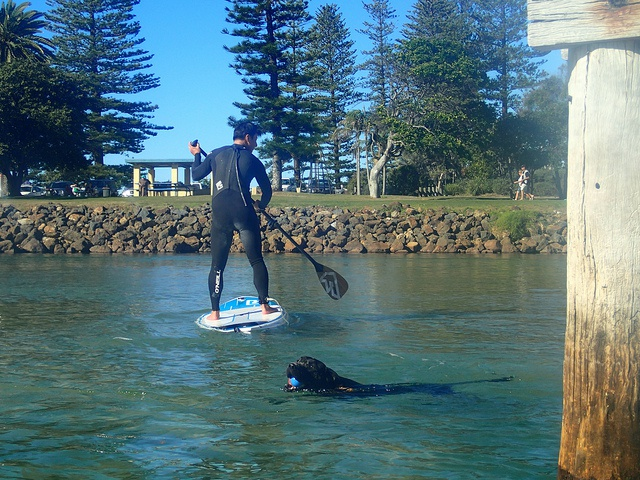Describe the objects in this image and their specific colors. I can see people in lightblue, navy, darkblue, gray, and black tones, dog in lightblue, black, teal, navy, and gray tones, surfboard in lightblue, lightgray, and gray tones, car in lightblue, navy, blue, and gray tones, and people in lightblue, gray, beige, and tan tones in this image. 